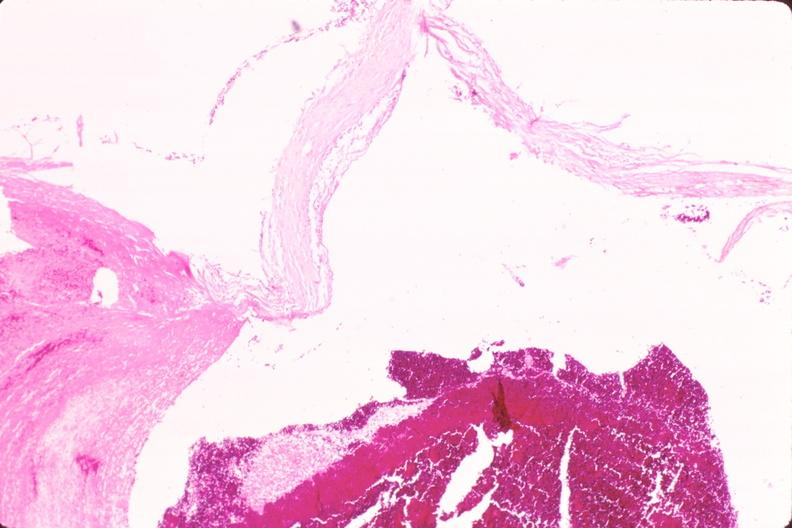where is this in?
Answer the question using a single word or phrase. In vasculature 